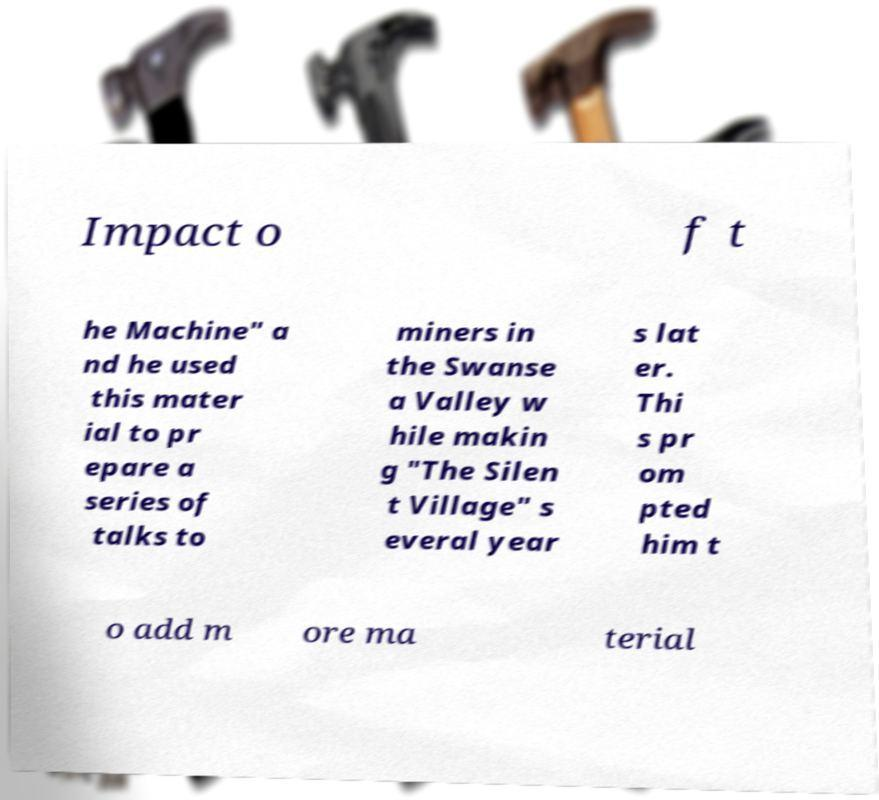For documentation purposes, I need the text within this image transcribed. Could you provide that? Impact o f t he Machine" a nd he used this mater ial to pr epare a series of talks to miners in the Swanse a Valley w hile makin g "The Silen t Village" s everal year s lat er. Thi s pr om pted him t o add m ore ma terial 